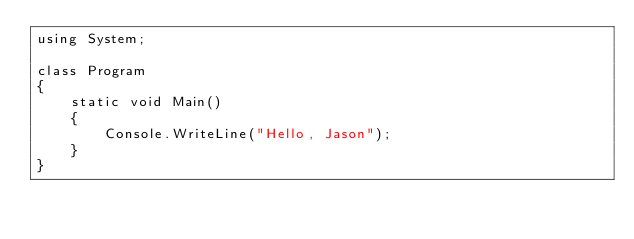<code> <loc_0><loc_0><loc_500><loc_500><_C#_>using System;

class Program
{
    static void Main()
    {
        Console.WriteLine("Hello, Jason");
    }
}
</code> 